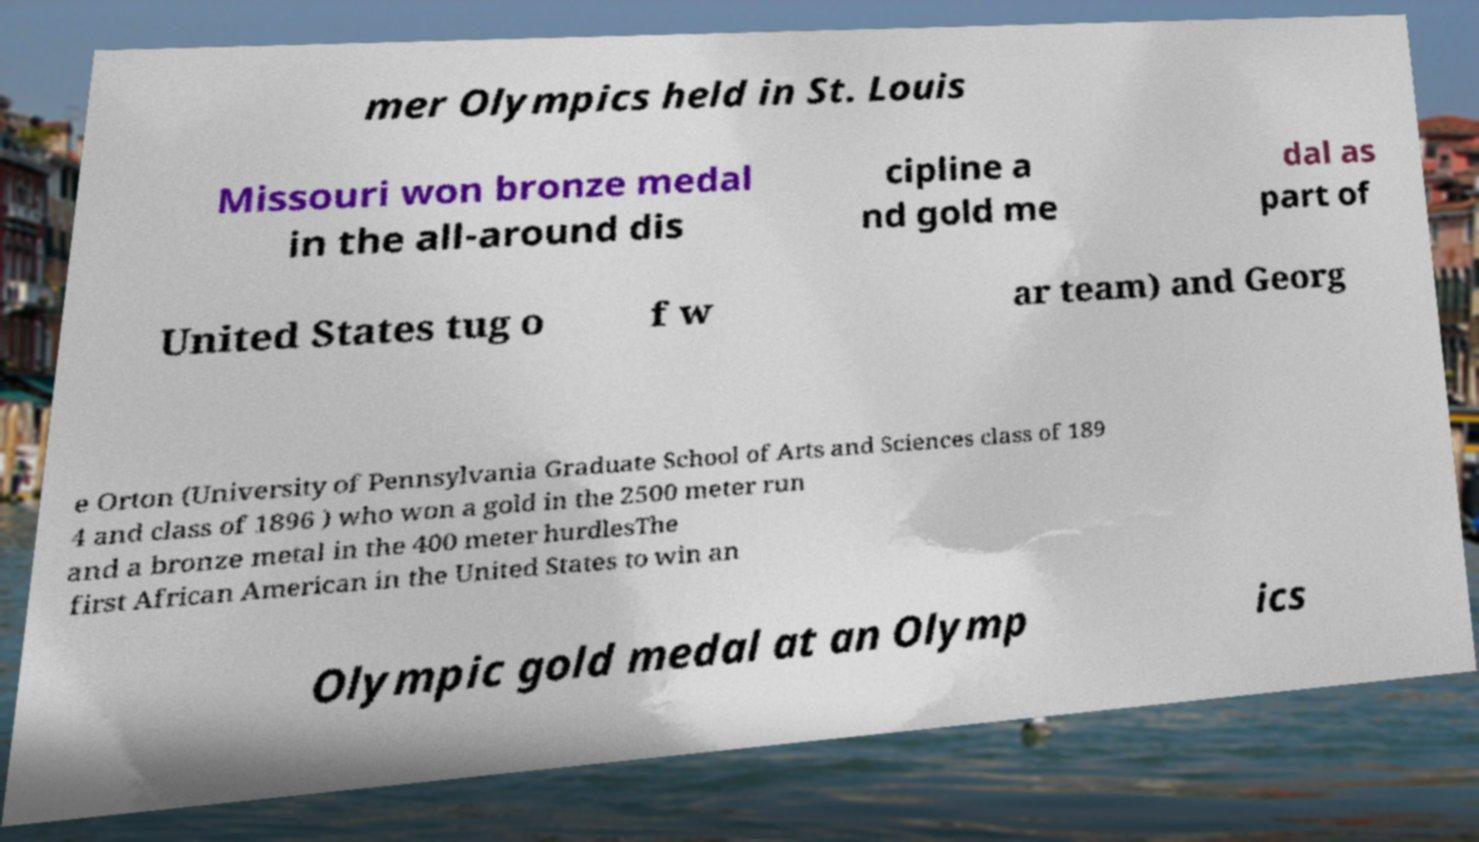Can you accurately transcribe the text from the provided image for me? mer Olympics held in St. Louis Missouri won bronze medal in the all-around dis cipline a nd gold me dal as part of United States tug o f w ar team) and Georg e Orton (University of Pennsylvania Graduate School of Arts and Sciences class of 189 4 and class of 1896 ) who won a gold in the 2500 meter run and a bronze metal in the 400 meter hurdlesThe first African American in the United States to win an Olympic gold medal at an Olymp ics 